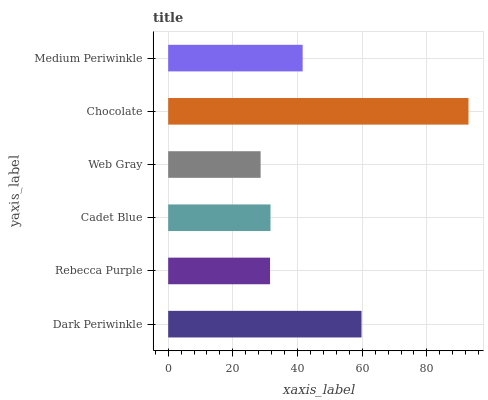Is Web Gray the minimum?
Answer yes or no. Yes. Is Chocolate the maximum?
Answer yes or no. Yes. Is Rebecca Purple the minimum?
Answer yes or no. No. Is Rebecca Purple the maximum?
Answer yes or no. No. Is Dark Periwinkle greater than Rebecca Purple?
Answer yes or no. Yes. Is Rebecca Purple less than Dark Periwinkle?
Answer yes or no. Yes. Is Rebecca Purple greater than Dark Periwinkle?
Answer yes or no. No. Is Dark Periwinkle less than Rebecca Purple?
Answer yes or no. No. Is Medium Periwinkle the high median?
Answer yes or no. Yes. Is Cadet Blue the low median?
Answer yes or no. Yes. Is Rebecca Purple the high median?
Answer yes or no. No. Is Web Gray the low median?
Answer yes or no. No. 